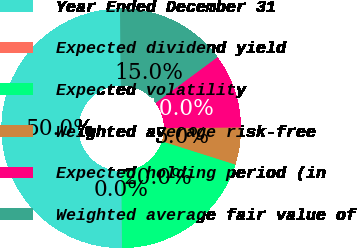Convert chart to OTSL. <chart><loc_0><loc_0><loc_500><loc_500><pie_chart><fcel>Year Ended December 31<fcel>Expected dividend yield<fcel>Expected volatility<fcel>Weighted average risk-free<fcel>Expected holding period (in<fcel>Weighted average fair value of<nl><fcel>49.97%<fcel>0.01%<fcel>20.0%<fcel>5.01%<fcel>10.01%<fcel>15.0%<nl></chart> 